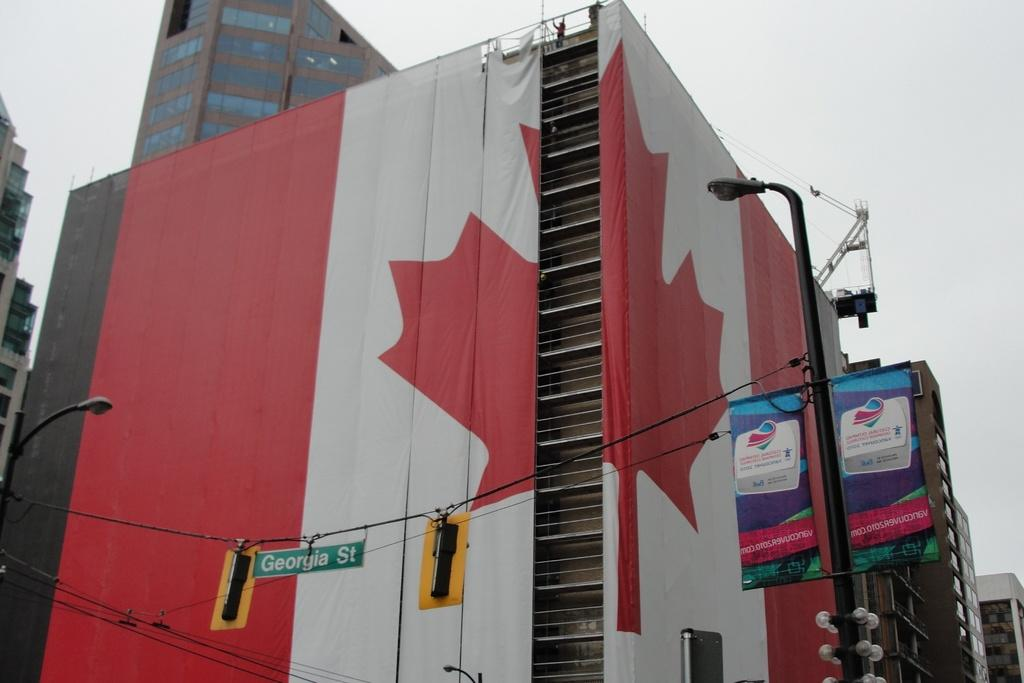<image>
Provide a brief description of the given image. a large Canadian Flag is draped on a building on Georgia St 